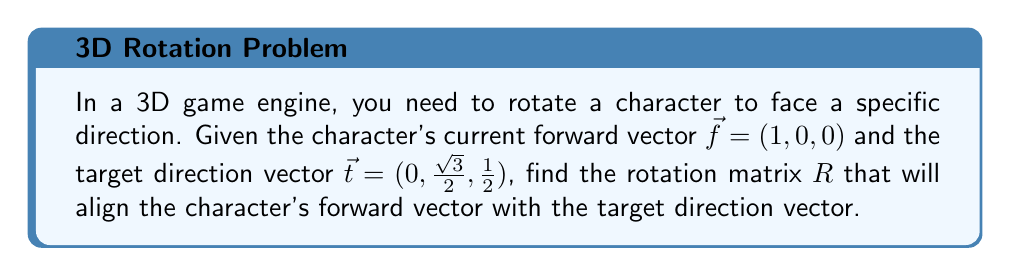Solve this math problem. To find the rotation matrix that aligns two vectors, we can use the following steps:

1. Calculate the axis of rotation:
   The axis of rotation is perpendicular to both vectors and can be found using the cross product:
   $$\vec{a} = \vec{f} \times \vec{t} = (1,0,0) \times (0,\frac{\sqrt{3}}{2},\frac{1}{2}) = (0, -\frac{1}{2}, \frac{\sqrt{3}}{2})$$

2. Normalize the axis of rotation:
   $$\vec{n} = \frac{\vec{a}}{|\vec{a}|} = (0, -\frac{1}{\sqrt{4}}, \frac{\sqrt{3}}{\sqrt{4}}) = (0, -\frac{1}{2}, \frac{\sqrt{3}}{2})$$

3. Calculate the angle of rotation:
   $$\cos \theta = \vec{f} \cdot \vec{t} = 1 \cdot 0 + 0 \cdot \frac{\sqrt{3}}{2} + 0 \cdot \frac{1}{2} = 0$$
   $$\theta = \arccos(0) = \frac{\pi}{2}$$

4. Use Rodrigues' rotation formula to construct the rotation matrix:
   $$R = I + (\sin \theta)[n]_\times + (1-\cos \theta)[n]_\times^2$$
   
   Where $I$ is the 3x3 identity matrix, and $[n]_\times$ is the skew-symmetric matrix of $\vec{n}$:
   $$[n]_\times = \begin{pmatrix}
   0 & -n_z & n_y \\
   n_z & 0 & -n_x \\
   -n_y & n_x & 0
   \end{pmatrix} = \begin{pmatrix}
   0 & -\frac{\sqrt{3}}{2} & -\frac{1}{2} \\
   \frac{\sqrt{3}}{2} & 0 & 0 \\
   \frac{1}{2} & 0 & 0
   \end{pmatrix}$$

5. Calculate the rotation matrix:
   $$R = \begin{pmatrix}
   1 & 0 & 0 \\
   0 & 1 & 0 \\
   0 & 0 & 1
   \end{pmatrix} + \sin(\frac{\pi}{2})\begin{pmatrix}
   0 & -\frac{\sqrt{3}}{2} & -\frac{1}{2} \\
   \frac{\sqrt{3}}{2} & 0 & 0 \\
   \frac{1}{2} & 0 & 0
   \end{pmatrix} + (1-\cos(\frac{\pi}{2}))\begin{pmatrix}
   -\frac{3}{4} & 0 & 0 \\
   0 & -\frac{1}{4} & -\frac{\sqrt{3}}{4} \\
   0 & -\frac{\sqrt{3}}{4} & -\frac{1}{4}
   \end{pmatrix}$$

   $$R = \begin{pmatrix}
   1 & 0 & 0 \\
   0 & 1 & 0 \\
   0 & 0 & 1
   \end{pmatrix} + \begin{pmatrix}
   0 & -\frac{\sqrt{3}}{2} & -\frac{1}{2} \\
   \frac{\sqrt{3}}{2} & 0 & 0 \\
   \frac{1}{2} & 0 & 0
   \end{pmatrix} + \begin{pmatrix}
   -\frac{3}{4} & 0 & 0 \\
   0 & -\frac{1}{4} & -\frac{\sqrt{3}}{4} \\
   0 & -\frac{\sqrt{3}}{4} & -\frac{1}{4}
   \end{pmatrix}$$

   $$R = \begin{pmatrix}
   \frac{1}{4} & -\frac{\sqrt{3}}{2} & -\frac{1}{2} \\
   \frac{\sqrt{3}}{2} & \frac{3}{4} & -\frac{\sqrt{3}}{4} \\
   \frac{1}{2} & \frac{\sqrt{3}}{4} & \frac{3}{4}
   \end{pmatrix}$$
Answer: $$R = \begin{pmatrix}
\frac{1}{4} & -\frac{\sqrt{3}}{2} & -\frac{1}{2} \\
\frac{\sqrt{3}}{2} & \frac{3}{4} & -\frac{\sqrt{3}}{4} \\
\frac{1}{2} & \frac{\sqrt{3}}{4} & \frac{3}{4}
\end{pmatrix}$$ 